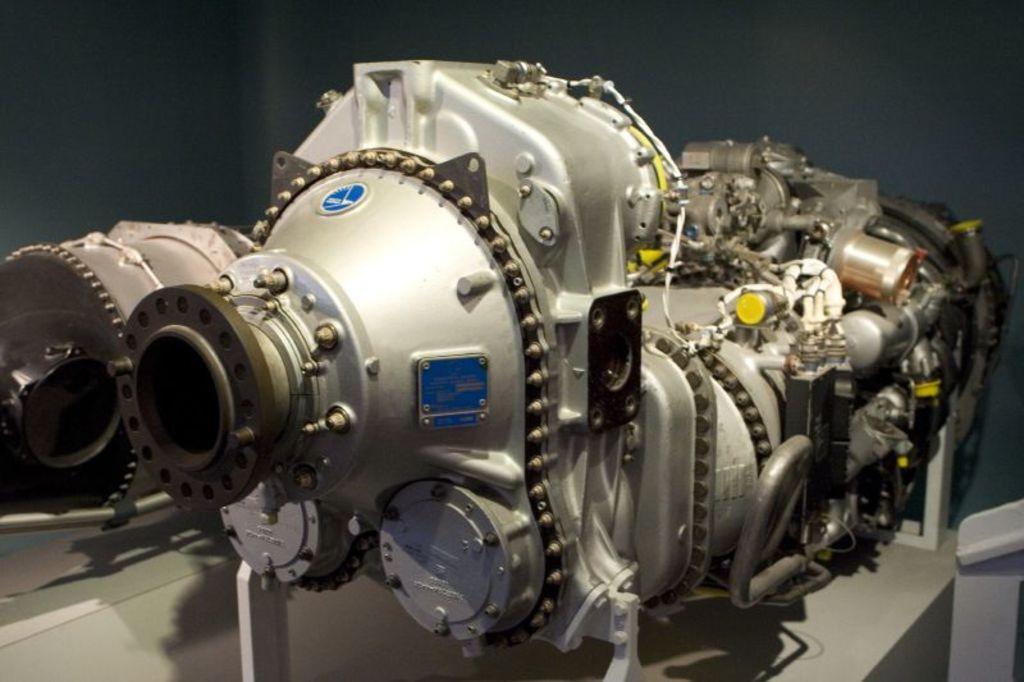In one or two sentences, can you explain what this image depicts? In this image we can see a machine and in the background, we can see the wall. 